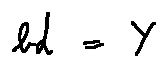<formula> <loc_0><loc_0><loc_500><loc_500>b d = Y</formula> 